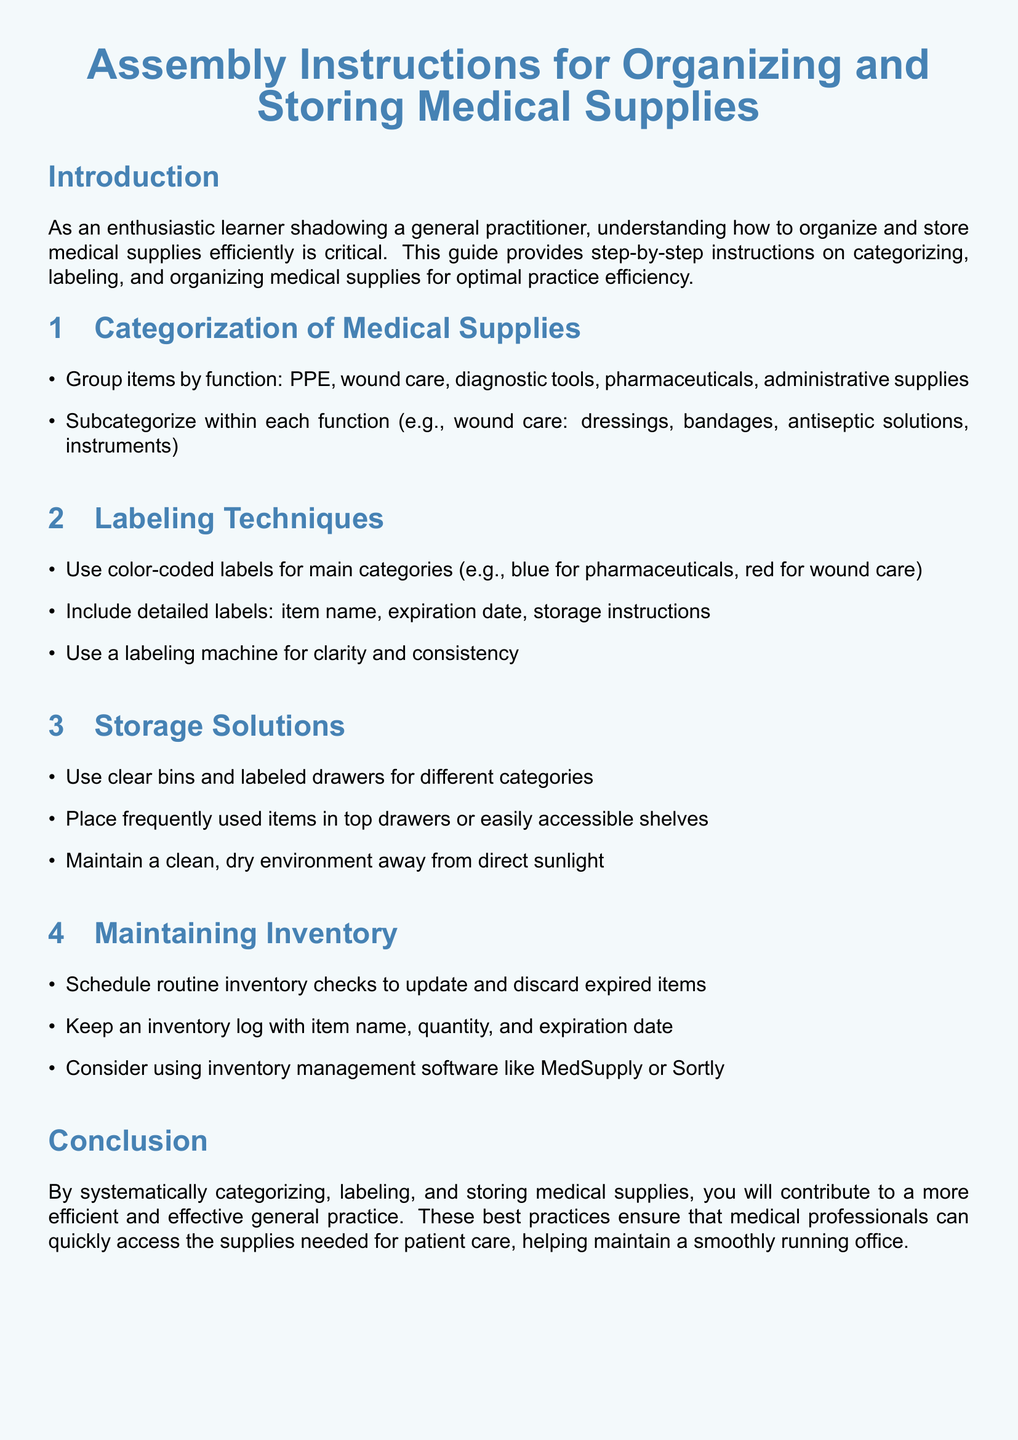What are two main categories of medical supplies? The document mentions grouping items by function, which includes PPE and wound care.
Answer: PPE, wound care What color is used for pharmaceutical labels? The document specifies that blue is used for pharmaceuticals within the labeling section.
Answer: Blue What should be included on detailed labels? The labeling techniques section indicates it includes item name, expiration date, and storage instructions.
Answer: Item name, expiration date, storage instructions How should frequently used items be stored? The document states that frequently used items should be placed in top drawers or easily accessible shelves.
Answer: Top drawers What is one recommended type of storage solution? The storage solutions section suggests using clear bins and labeled drawers for different categories.
Answer: Clear bins and labeled drawers What is the purpose of routine inventory checks? The maintaining inventory section notes that routine checks are for updating and discarding expired items.
Answer: Update and discard expired items What software is suggested for inventory management? The inventory section suggests using MedSupply or Sortly for managing inventory.
Answer: MedSupply or Sortly What is the overall goal of organizing medical supplies according to the document? The conclusion states that these practices contribute to a more efficient and effective general practice.
Answer: Efficiency and effectiveness 